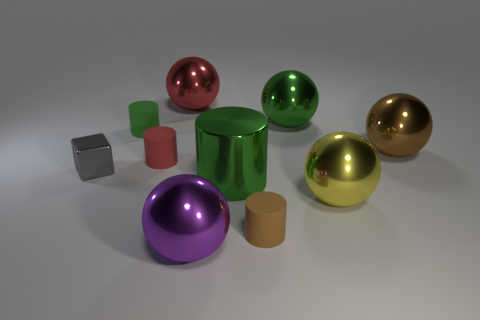Subtract all green blocks. How many green cylinders are left? 2 Subtract all big purple metallic balls. How many balls are left? 4 Subtract all yellow balls. How many balls are left? 4 Subtract all yellow cylinders. Subtract all brown cubes. How many cylinders are left? 4 Subtract all blocks. How many objects are left? 9 Add 6 brown spheres. How many brown spheres are left? 7 Add 1 big shiny cylinders. How many big shiny cylinders exist? 2 Subtract 1 red cylinders. How many objects are left? 9 Subtract all big green spheres. Subtract all red rubber things. How many objects are left? 8 